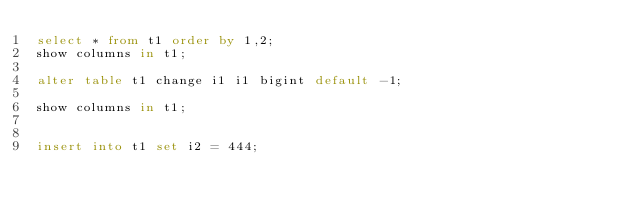Convert code to text. <code><loc_0><loc_0><loc_500><loc_500><_SQL_>select * from t1 order by 1,2;
show columns in t1;

alter table t1 change i1 i1 bigint default -1;

show columns in t1;


insert into t1 set i2 = 444;</code> 